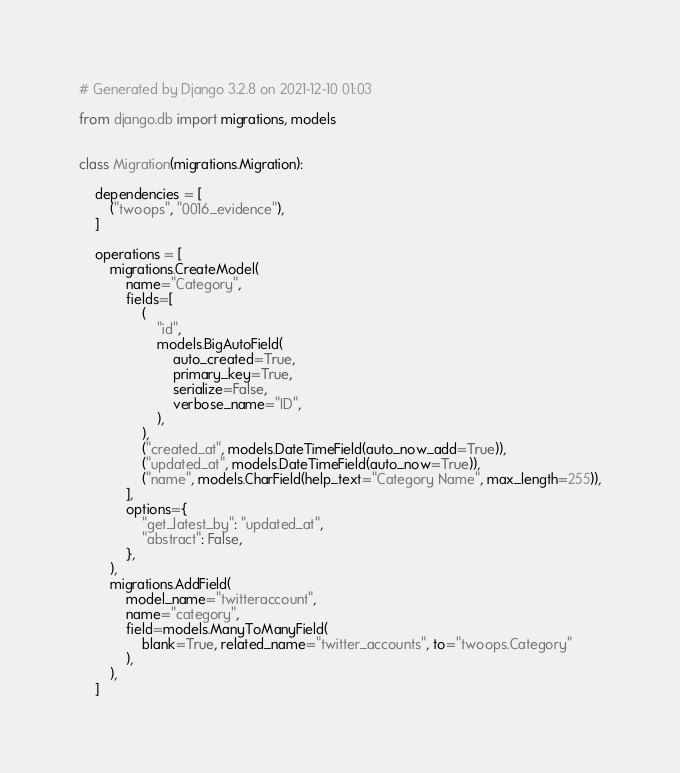<code> <loc_0><loc_0><loc_500><loc_500><_Python_># Generated by Django 3.2.8 on 2021-12-10 01:03

from django.db import migrations, models


class Migration(migrations.Migration):

    dependencies = [
        ("twoops", "0016_evidence"),
    ]

    operations = [
        migrations.CreateModel(
            name="Category",
            fields=[
                (
                    "id",
                    models.BigAutoField(
                        auto_created=True,
                        primary_key=True,
                        serialize=False,
                        verbose_name="ID",
                    ),
                ),
                ("created_at", models.DateTimeField(auto_now_add=True)),
                ("updated_at", models.DateTimeField(auto_now=True)),
                ("name", models.CharField(help_text="Category Name", max_length=255)),
            ],
            options={
                "get_latest_by": "updated_at",
                "abstract": False,
            },
        ),
        migrations.AddField(
            model_name="twitteraccount",
            name="category",
            field=models.ManyToManyField(
                blank=True, related_name="twitter_accounts", to="twoops.Category"
            ),
        ),
    ]
</code> 